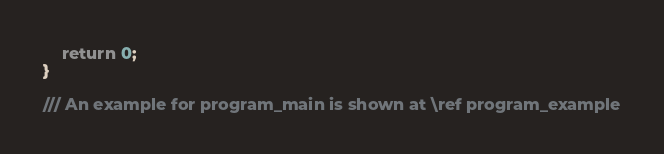<code> <loc_0><loc_0><loc_500><loc_500><_C++_>    return 0;
}

/// An example for program_main is shown at \ref program_example

</code> 